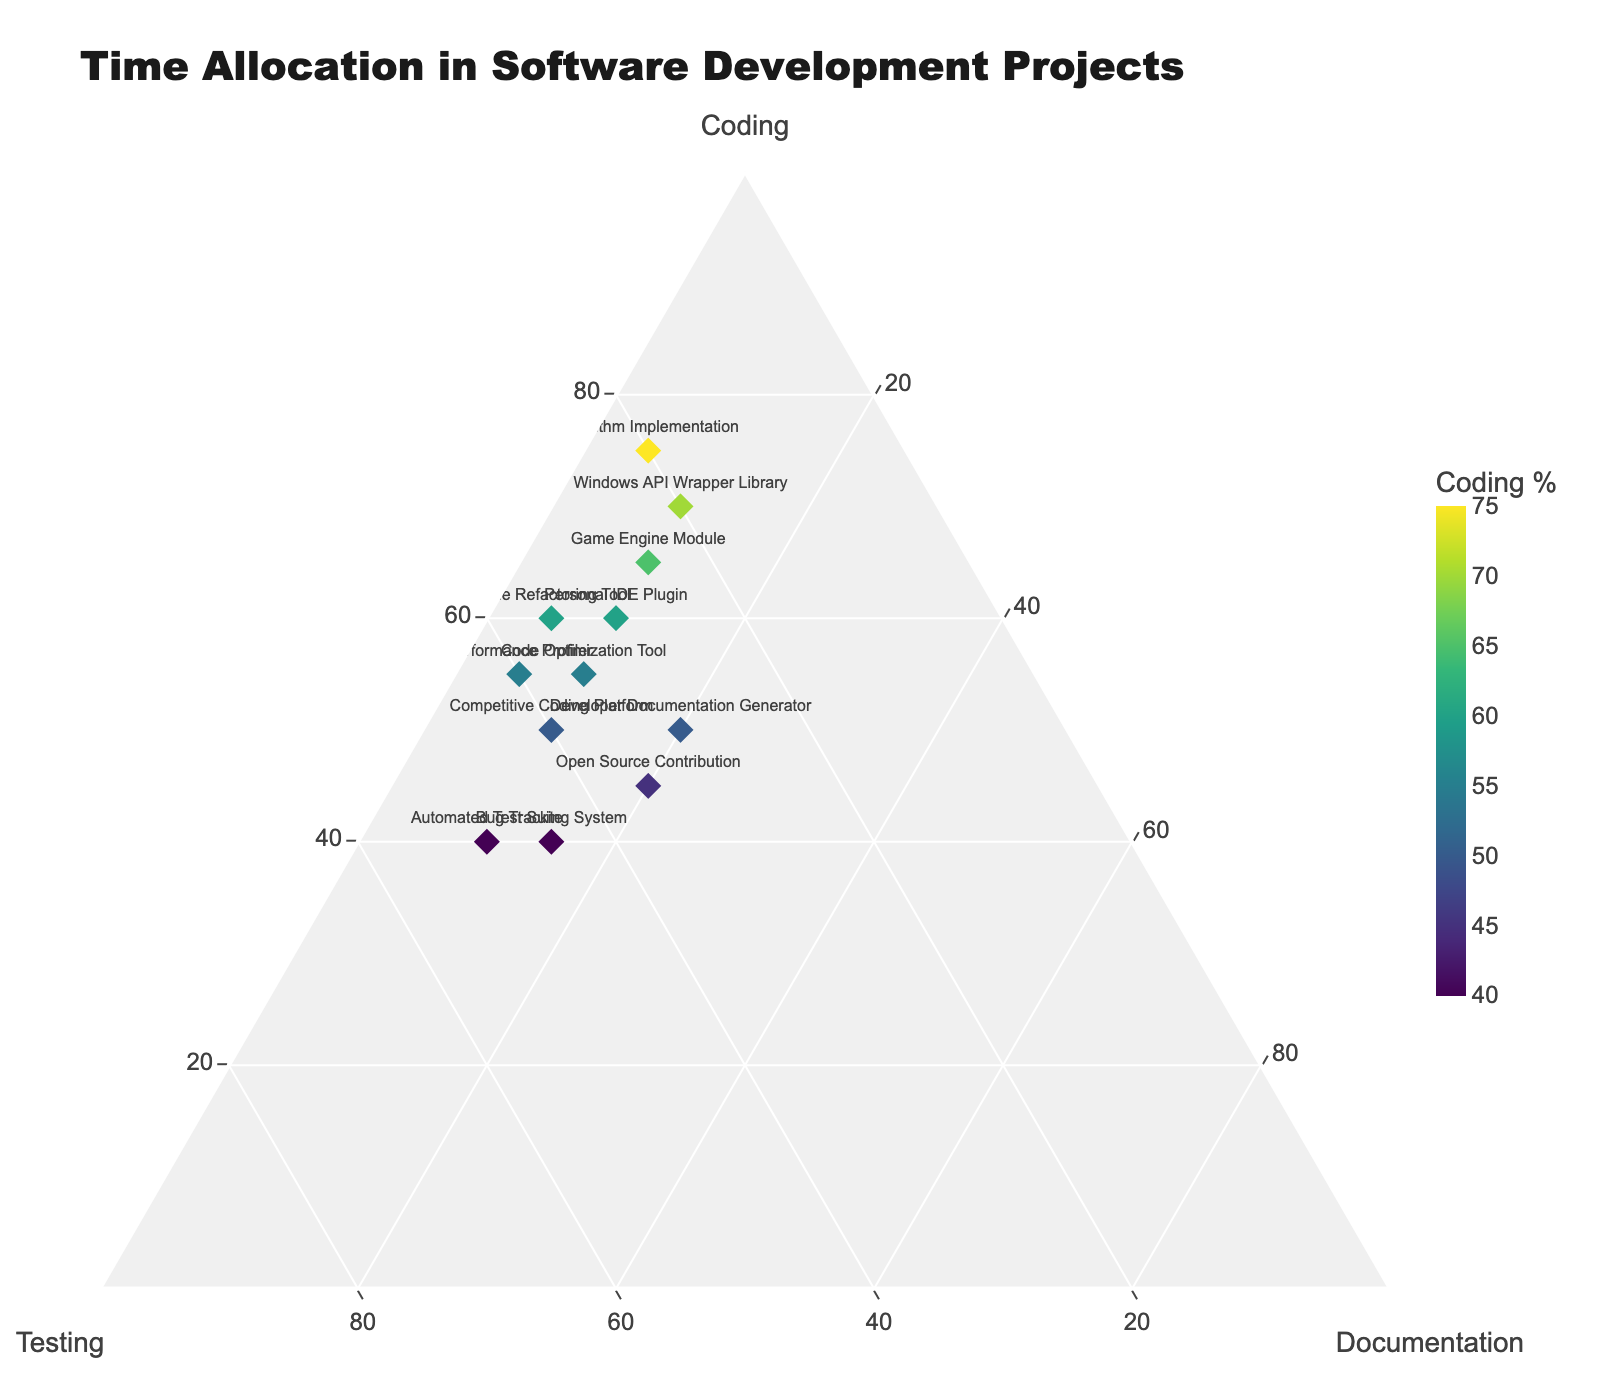How many projects are represented in the plot? By counting the number of markers or data points in the plot, we can determine the total number of projects. Each marker represents one project.
Answer: 12 What is the title of the ternary plot? The title of the ternary plot is usually displayed prominently at the top of the plot.
Answer: Time Allocation in Software Development Projects Which project allocates the highest percentage to Coding? In the ternary plot, each marker's percentage allocation to Coding is represented along the axis labeled 'Coding'. Identify the project with the marker positioned farthest towards the Coding axis.
Answer: Algorithm Implementation Which project allocates the highest percentage to Documentation? Documentation allocation is represented along the axis labeled 'Documentation'. Identify the project with the marker closest to the Documentation axis.
Answer: Open Source Contribution What is the average percentage allocation to Testing across all projects? To find the average, sum the percentages for Testing from all projects and then divide by the number of projects. The Testing percentages are 30, 40, 20, 50, 35, 35, 25, 30, 20, 40, 45, 35. Sum them up: 30 + 40 + 20 + 50 + 35 + 35 + 25 + 30 + 20 + 40 + 45 + 35 = 405. Now divide by 12 (the number of projects): 405 / 12 = 33.75.
Answer: 33.75 Which two projects have the same allocation percentages for Documentation? Identify markers positioned at the same vertical level along the 'Documentation' axis to find projects with identical Documentation percentages.
Answer: Personal IDE Plugin and Competitive Coding Platform Compare the Coding and Testing allocation between the 'Code Optimization Tool' and 'Code Refactoring Tool'. Which one allocates more to Coding and less to Testing? Find the locations of the two projects along the Coding and Testing axes. 'Code Optimization Tool' has 55% Coding, 35% Testing, whereas 'Code Refactoring Tool' has 60% Coding, 35% Testing.
Answer: Code Refactoring Tool allocates more to Coding and less to Testing What is the range of Documentation allocation percentages across all projects? Identify the minimum and maximum percentages in the Documentation axis and then calculate the range by subtracting the minimum value from the maximum value. The range is derived by subtracting the smallest documentation percentage (5%) from the largest (20%).
Answer: 15 Based on the plot, which type of projects tend to have higher Coding percentages? By observing the plot, generalize which types of projects (e.g. related to competitive coding, API, optimization) are positioned closer to the Coding apex. Projects like 'Algorithm Implementation', 'Windows API Wrapper Library', and 'Game Engine Module' tend to have higher Coding percentages.
Answer: Algorithm Implementation, Windows API Wrapper Library, Game Engine Module Which project equally balances between Coding and Documentation while still allocating a substantial amount to Testing? Look for a project marker that is positioned somewhat centrally between the Coding and Documentation axes but also away from the origin, indicating substantial Testing allocation. The 'Developer Documentation Generator' has 20% Documentation, 50% Coding and 30% Testing, showing a relative balance.
Answer: Developer Documentation Generator 